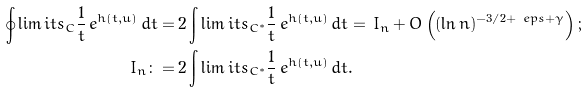Convert formula to latex. <formula><loc_0><loc_0><loc_500><loc_500>\oint \lim i t s _ { C } \frac { 1 } { t } \, e ^ { h ( t , u ) } \, d t = & \, 2 \int \lim i t s _ { C ^ { * } } \frac { 1 } { t } \, e ^ { h ( t , u ) } \, d t = \, I _ { n } + O \left ( ( \ln n ) ^ { - 3 / 2 + \ e p s + \gamma } \right ) ; \\ I _ { n } \colon = & \, 2 \int \lim i t s _ { C ^ { * } } \frac { 1 } { t } \, e ^ { h ( t , \bar { u } ) } \, d t .</formula> 